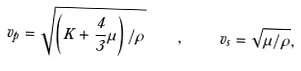<formula> <loc_0><loc_0><loc_500><loc_500>v _ { p } = \sqrt { \left ( K + \frac { 4 } { 3 } \mu \right ) / \rho } \quad , \quad v _ { s } = \sqrt { \mu / \rho } ,</formula> 